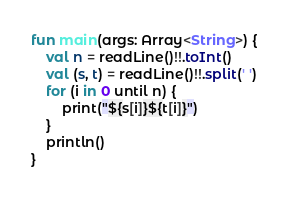Convert code to text. <code><loc_0><loc_0><loc_500><loc_500><_Kotlin_>fun main(args: Array<String>) {
    val n = readLine()!!.toInt()
    val (s, t) = readLine()!!.split(' ')
    for (i in 0 until n) {
        print("${s[i]}${t[i]}")
    }
    println()
}
</code> 